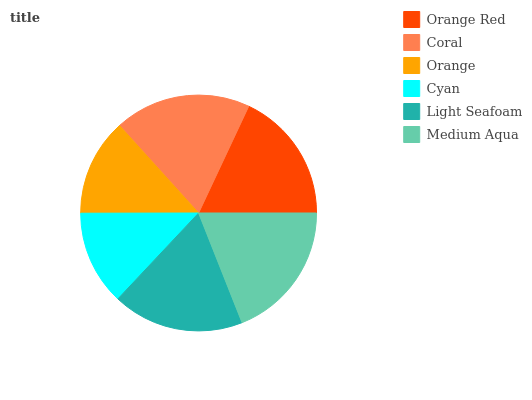Is Cyan the minimum?
Answer yes or no. Yes. Is Medium Aqua the maximum?
Answer yes or no. Yes. Is Coral the minimum?
Answer yes or no. No. Is Coral the maximum?
Answer yes or no. No. Is Coral greater than Orange Red?
Answer yes or no. Yes. Is Orange Red less than Coral?
Answer yes or no. Yes. Is Orange Red greater than Coral?
Answer yes or no. No. Is Coral less than Orange Red?
Answer yes or no. No. Is Orange Red the high median?
Answer yes or no. Yes. Is Light Seafoam the low median?
Answer yes or no. Yes. Is Coral the high median?
Answer yes or no. No. Is Cyan the low median?
Answer yes or no. No. 